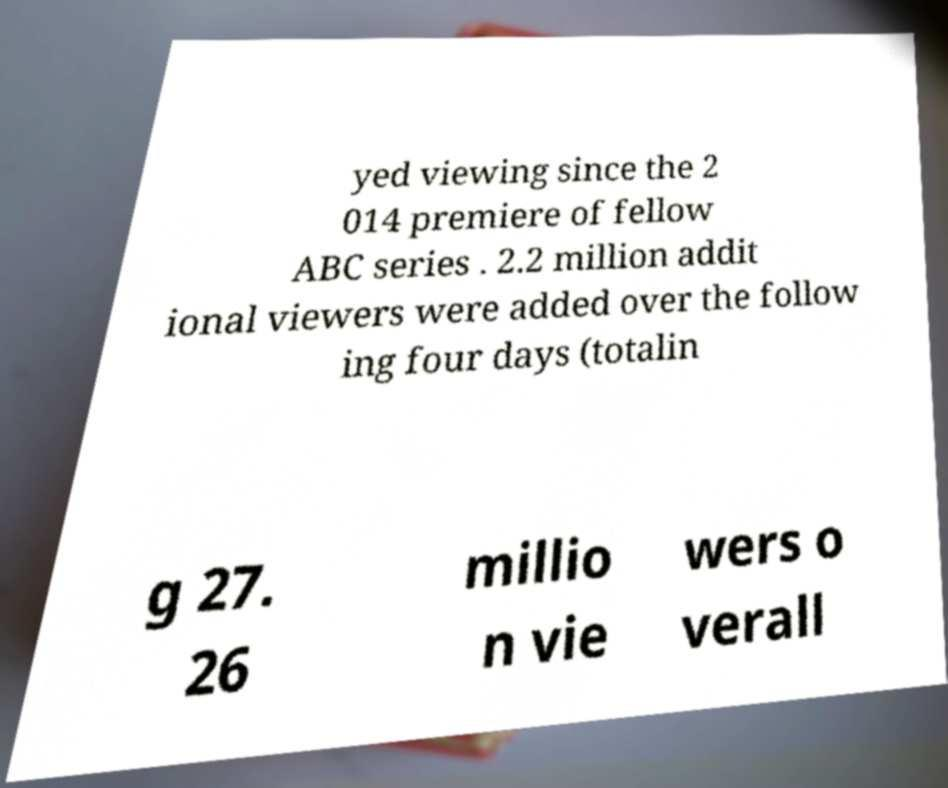For documentation purposes, I need the text within this image transcribed. Could you provide that? yed viewing since the 2 014 premiere of fellow ABC series . 2.2 million addit ional viewers were added over the follow ing four days (totalin g 27. 26 millio n vie wers o verall 